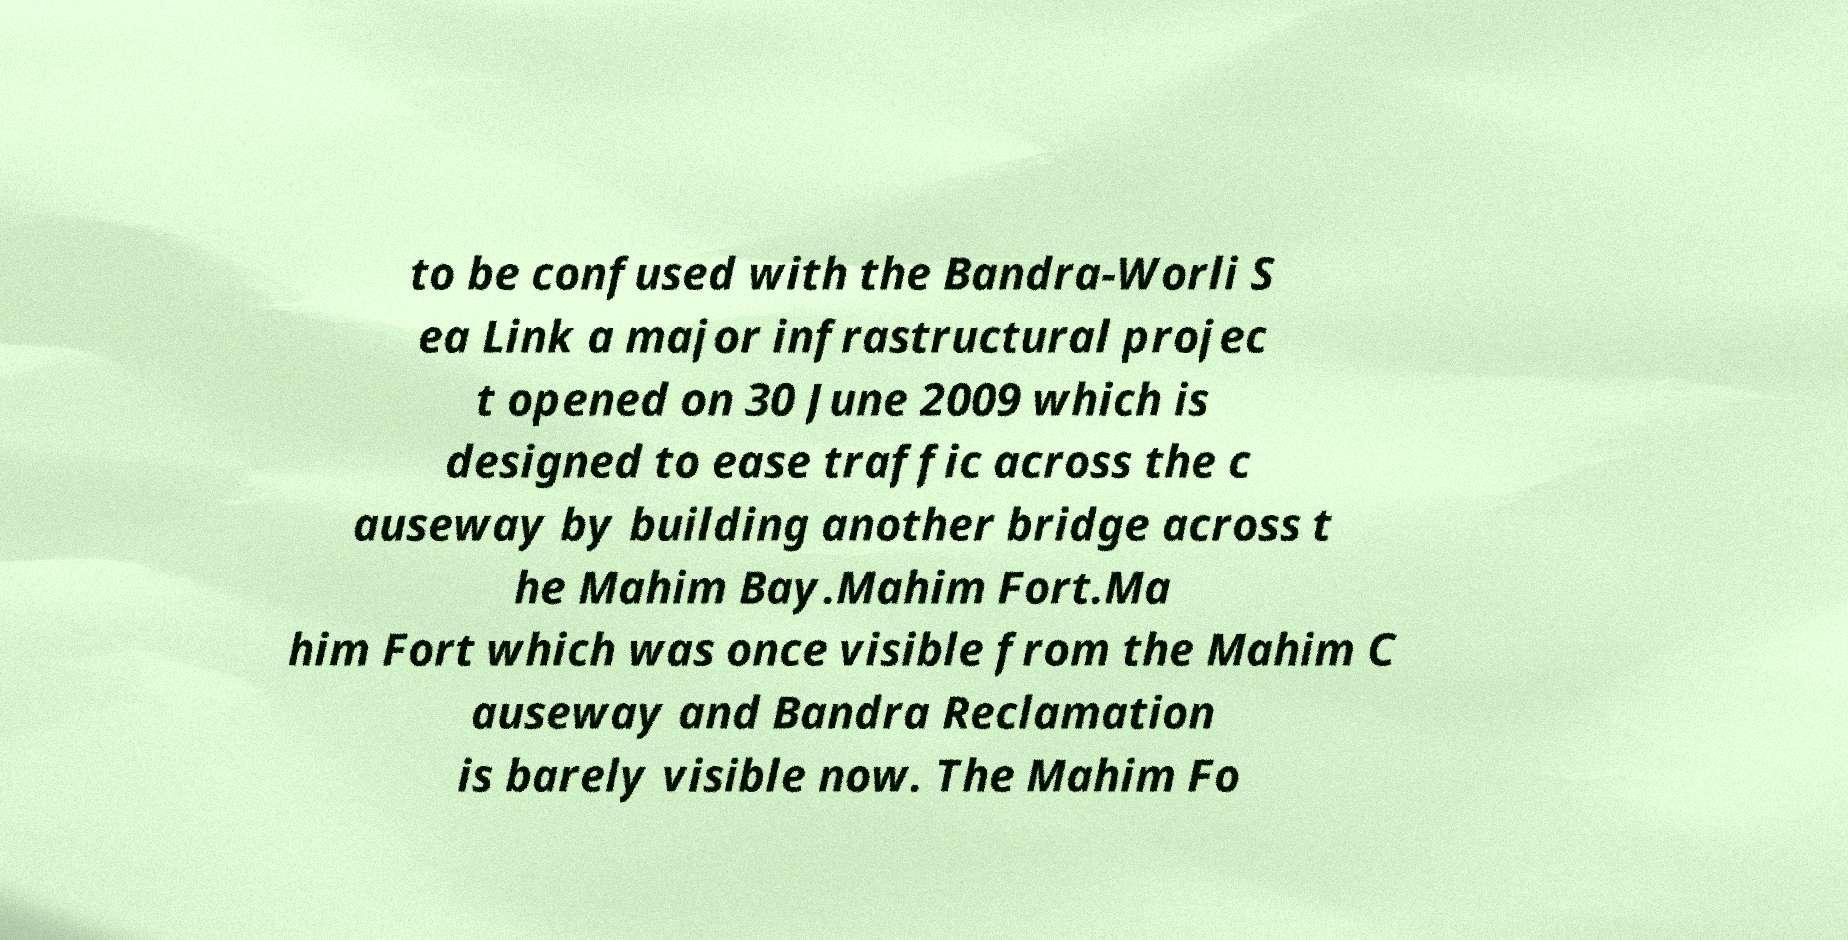Can you accurately transcribe the text from the provided image for me? to be confused with the Bandra-Worli S ea Link a major infrastructural projec t opened on 30 June 2009 which is designed to ease traffic across the c auseway by building another bridge across t he Mahim Bay.Mahim Fort.Ma him Fort which was once visible from the Mahim C auseway and Bandra Reclamation is barely visible now. The Mahim Fo 